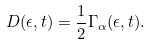Convert formula to latex. <formula><loc_0><loc_0><loc_500><loc_500>D ( \epsilon , t ) = \frac { 1 } { 2 } \Gamma _ { \alpha } ( \epsilon , t ) .</formula> 